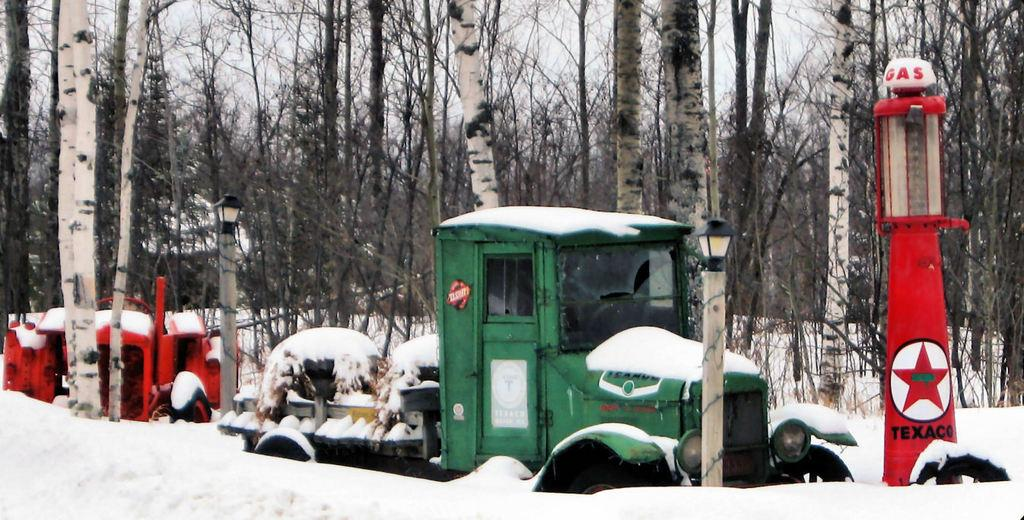What types of objects can be seen in the image? There are vehicles, light poles, a gas pump, and trees visible in the image. What is the weather like in the image? There is snow visible in the image, indicating a snowy or wintery scene. What can be seen in the background of the image? The sky is visible in the background of the image. Where is the scarecrow standing in the image? There is no scarecrow present in the image. What is the value of the cracker in the image? There is no cracker present in the image, so it is not possible to determine its value. 